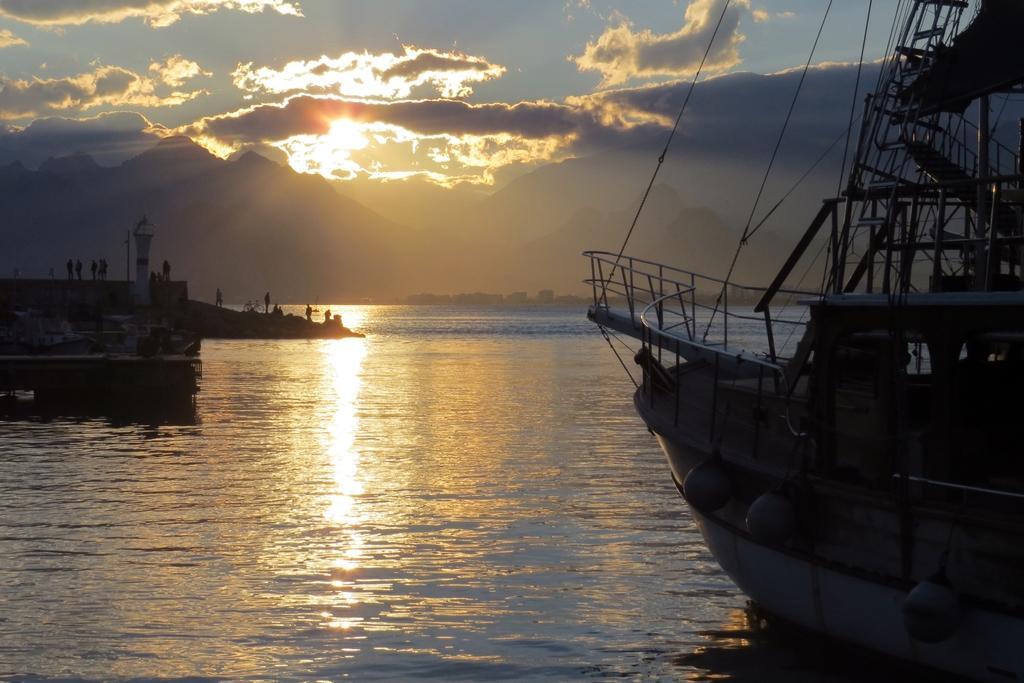Describe this image in one or two sentences. In this image I can see the lake and there is a boat visible on the lake on the right side, at the top I can see the sky and on the sky I can see a sunlight in front of the lake I can see the wall , and pole and on the wall I can see persons and bicycle visible on left side 